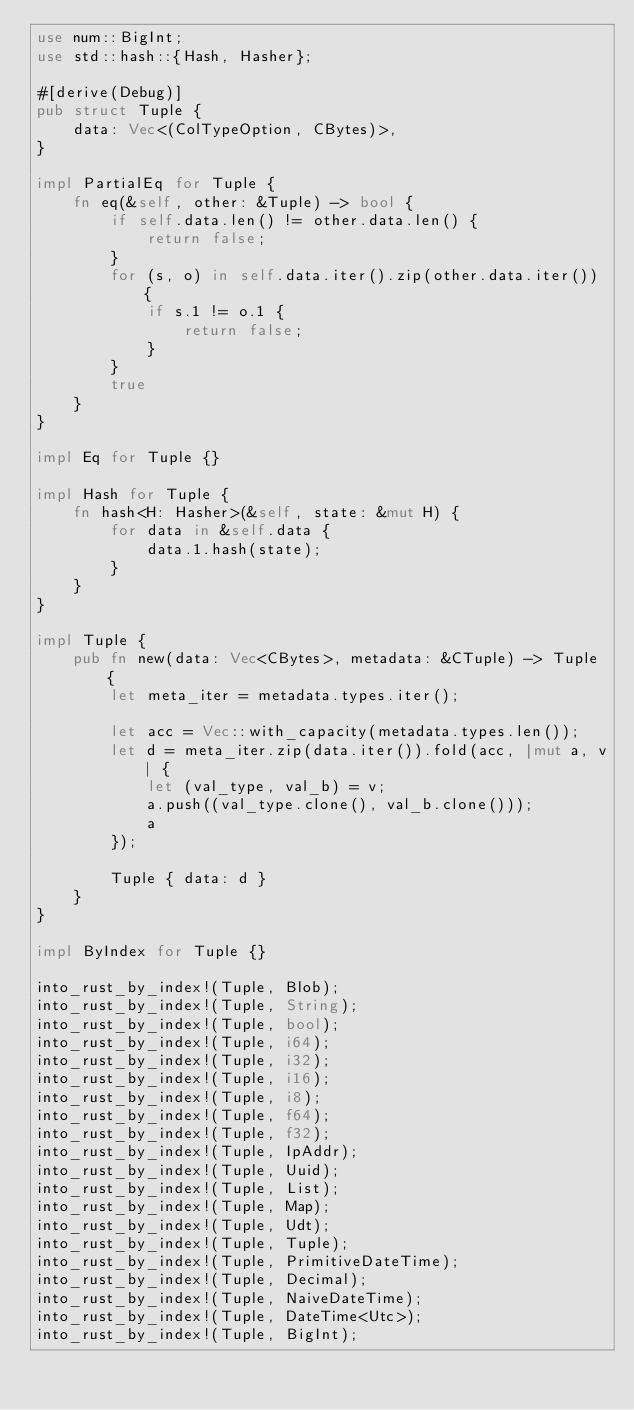Convert code to text. <code><loc_0><loc_0><loc_500><loc_500><_Rust_>use num::BigInt;
use std::hash::{Hash, Hasher};

#[derive(Debug)]
pub struct Tuple {
    data: Vec<(ColTypeOption, CBytes)>,
}

impl PartialEq for Tuple {
    fn eq(&self, other: &Tuple) -> bool {
        if self.data.len() != other.data.len() {
            return false;
        }
        for (s, o) in self.data.iter().zip(other.data.iter()) {
            if s.1 != o.1 {
                return false;
            }
        }
        true
    }
}

impl Eq for Tuple {}

impl Hash for Tuple {
    fn hash<H: Hasher>(&self, state: &mut H) {
        for data in &self.data {
            data.1.hash(state);
        }
    }
}

impl Tuple {
    pub fn new(data: Vec<CBytes>, metadata: &CTuple) -> Tuple {
        let meta_iter = metadata.types.iter();

        let acc = Vec::with_capacity(metadata.types.len());
        let d = meta_iter.zip(data.iter()).fold(acc, |mut a, v| {
            let (val_type, val_b) = v;
            a.push((val_type.clone(), val_b.clone()));
            a
        });

        Tuple { data: d }
    }
}

impl ByIndex for Tuple {}

into_rust_by_index!(Tuple, Blob);
into_rust_by_index!(Tuple, String);
into_rust_by_index!(Tuple, bool);
into_rust_by_index!(Tuple, i64);
into_rust_by_index!(Tuple, i32);
into_rust_by_index!(Tuple, i16);
into_rust_by_index!(Tuple, i8);
into_rust_by_index!(Tuple, f64);
into_rust_by_index!(Tuple, f32);
into_rust_by_index!(Tuple, IpAddr);
into_rust_by_index!(Tuple, Uuid);
into_rust_by_index!(Tuple, List);
into_rust_by_index!(Tuple, Map);
into_rust_by_index!(Tuple, Udt);
into_rust_by_index!(Tuple, Tuple);
into_rust_by_index!(Tuple, PrimitiveDateTime);
into_rust_by_index!(Tuple, Decimal);
into_rust_by_index!(Tuple, NaiveDateTime);
into_rust_by_index!(Tuple, DateTime<Utc>);
into_rust_by_index!(Tuple, BigInt);
</code> 